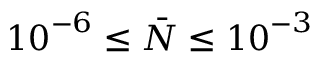Convert formula to latex. <formula><loc_0><loc_0><loc_500><loc_500>{ { 1 0 } ^ { - 6 } } \leq \bar { N } \leq { { 1 0 } ^ { - 3 } }</formula> 